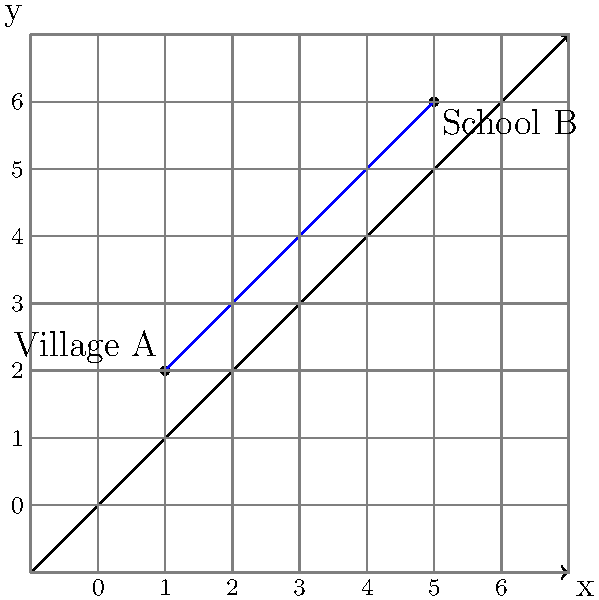In your village, you're learning about maps and distances. On a special map of your area, your village (A) is marked at the point (1, 2), and the nearest school (B) is at (5, 6). If each unit on the map represents 1 kilometer, how far is the school from your village? Round your answer to the nearest tenth of a kilometer. Let's solve this step-by-step:

1) We can use the distance formula to find the distance between two points. The formula is:

   $$d = \sqrt{(x_2 - x_1)^2 + (y_2 - y_1)^2}$$

   Where $(x_1, y_1)$ is the coordinate of the first point and $(x_2, y_2)$ is the coordinate of the second point.

2) In this case:
   Village A: $(x_1, y_1) = (1, 2)$
   School B: $(x_2, y_2) = (5, 6)$

3) Let's plug these into the formula:

   $$d = \sqrt{(5 - 1)^2 + (6 - 2)^2}$$

4) Simplify inside the parentheses:

   $$d = \sqrt{4^2 + 4^2}$$

5) Calculate the squares:

   $$d = \sqrt{16 + 16}$$

6) Add inside the square root:

   $$d = \sqrt{32}$$

7) Simplify the square root:

   $$d = 4\sqrt{2} \approx 5.66$$

8) Rounding to the nearest tenth:

   $$d \approx 5.7$$

9) Since each unit represents 1 kilometer, the distance is approximately 5.7 kilometers.
Answer: 5.7 km 